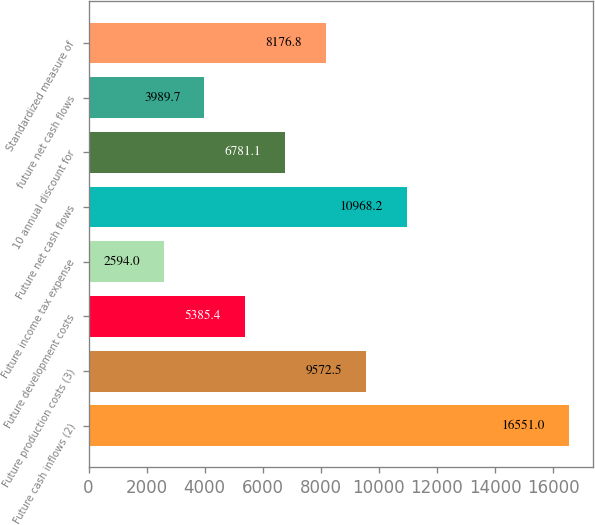<chart> <loc_0><loc_0><loc_500><loc_500><bar_chart><fcel>Future cash inflows (2)<fcel>Future production costs (3)<fcel>Future development costs<fcel>Future income tax expense<fcel>Future net cash flows<fcel>10 annual discount for<fcel>future net cash flows<fcel>Standardized measure of<nl><fcel>16551<fcel>9572.5<fcel>5385.4<fcel>2594<fcel>10968.2<fcel>6781.1<fcel>3989.7<fcel>8176.8<nl></chart> 